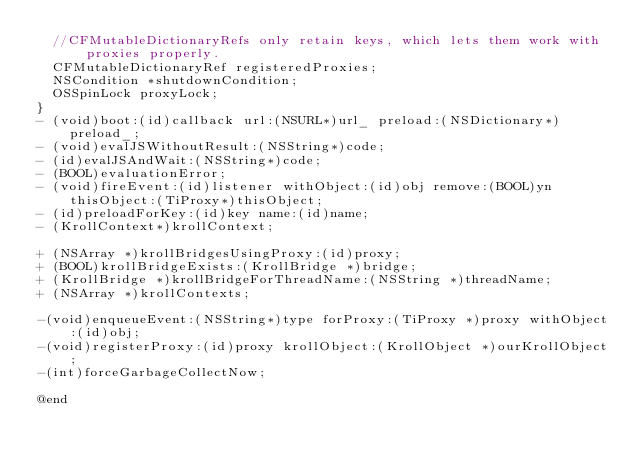<code> <loc_0><loc_0><loc_500><loc_500><_C_>	//CFMutableDictionaryRefs only retain keys, which lets them work with proxies properly.
	CFMutableDictionaryRef registeredProxies;
	NSCondition *shutdownCondition;
	OSSpinLock proxyLock;
}
- (void)boot:(id)callback url:(NSURL*)url_ preload:(NSDictionary*)preload_;
- (void)evalJSWithoutResult:(NSString*)code;
- (id)evalJSAndWait:(NSString*)code;
- (BOOL)evaluationError;
- (void)fireEvent:(id)listener withObject:(id)obj remove:(BOOL)yn thisObject:(TiProxy*)thisObject;
- (id)preloadForKey:(id)key name:(id)name;
- (KrollContext*)krollContext;

+ (NSArray *)krollBridgesUsingProxy:(id)proxy;
+ (BOOL)krollBridgeExists:(KrollBridge *)bridge;
+ (KrollBridge *)krollBridgeForThreadName:(NSString *)threadName;
+ (NSArray *)krollContexts;

-(void)enqueueEvent:(NSString*)type forProxy:(TiProxy *)proxy withObject:(id)obj;
-(void)registerProxy:(id)proxy krollObject:(KrollObject *)ourKrollObject;
-(int)forceGarbageCollectNow;

@end

</code> 